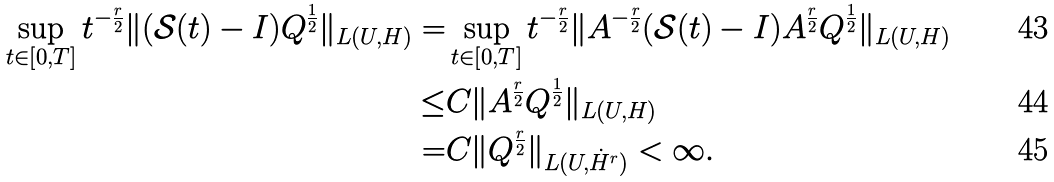Convert formula to latex. <formula><loc_0><loc_0><loc_500><loc_500>\sup _ { t \in [ 0 , T ] } t ^ { - \frac { r } { 2 } } \| ( \mathcal { S } ( t ) - I ) Q ^ { \frac { 1 } { 2 } } \| _ { L ( U , H ) } = & \sup _ { t \in [ 0 , T ] } t ^ { - \frac { r } { 2 } } \| A ^ { - \frac { r } { 2 } } ( \mathcal { S } ( t ) - I ) A ^ { \frac { r } { 2 } } Q ^ { \frac { 1 } { 2 } } \| _ { L ( U , H ) } \\ \leq & C \| A ^ { \frac { r } { 2 } } Q ^ { \frac { 1 } { 2 } } \| _ { L ( U , H ) } \\ = & C \| Q ^ { \frac { r } { 2 } } \| _ { L ( U , \dot { H } ^ { r } ) } < \infty .</formula> 